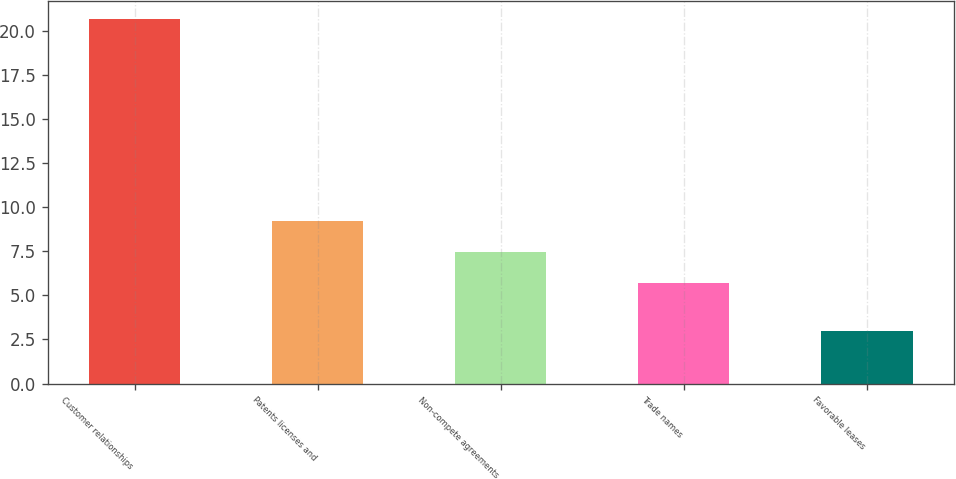<chart> <loc_0><loc_0><loc_500><loc_500><bar_chart><fcel>Customer relationships<fcel>Patents licenses and<fcel>Non-compete agreements<fcel>Trade names<fcel>Favorable leases<nl><fcel>20.7<fcel>9.24<fcel>7.47<fcel>5.7<fcel>3<nl></chart> 